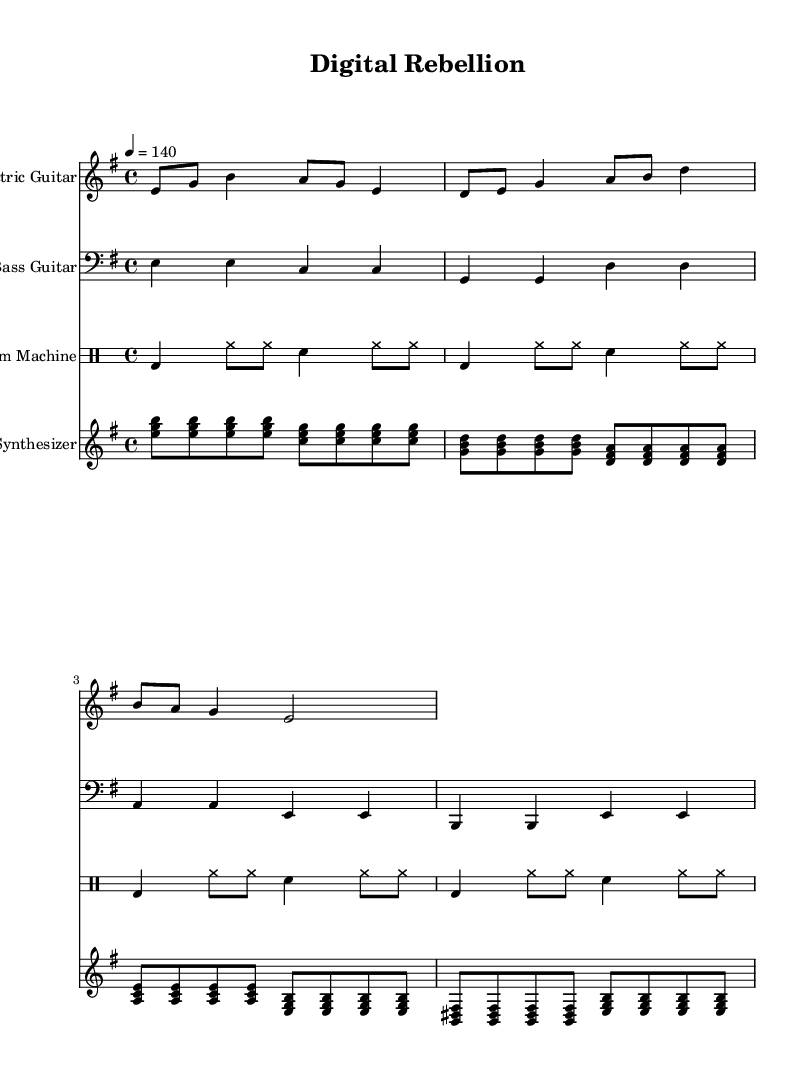What is the key signature of this music? The key signature for the piece is E minor, which is indicated by one sharp in the key signature (F#). This can be identified at the beginning of the sheet music.
Answer: E minor What is the time signature of the piece? The time signature is 4/4, which is shown at the beginning of the score. This indicates that there are four beats in each measure and the quarter note gets one beat.
Answer: 4/4 What is the tempo marking for the music? The tempo marking is 4 = 140, specifying a quarter note beats per minute of 140. This means the music is to be played at a fast pace, characteristic of punk music.
Answer: 140 How many different instrumental parts are there in the score? There are four instrumental parts: Electric Guitar, Bass Guitar, Drum Machine, and Synthesizer. Each part is separated visually in the score, making it easy to identify them.
Answer: Four Which instrument plays the bass line? The instrument playing the bass line is the Bass Guitar, which is notated in the bass clef and provides the foundational harmonic support for the piece.
Answer: Bass Guitar What defines the electronic element in this post-punk piece? The electronic element is represented by the Synthesizer, which uses chords and rhythmic patterns to create a distinct sound, separate from traditional instruments like the guitar and drums.
Answer: Synthesizer Is the music considered to have repetitive elements? Yes, the music features repetitive patterns, especially in the synthesizer and drum machine parts, typical of the electronic components in experimental post-punk music.
Answer: Yes 